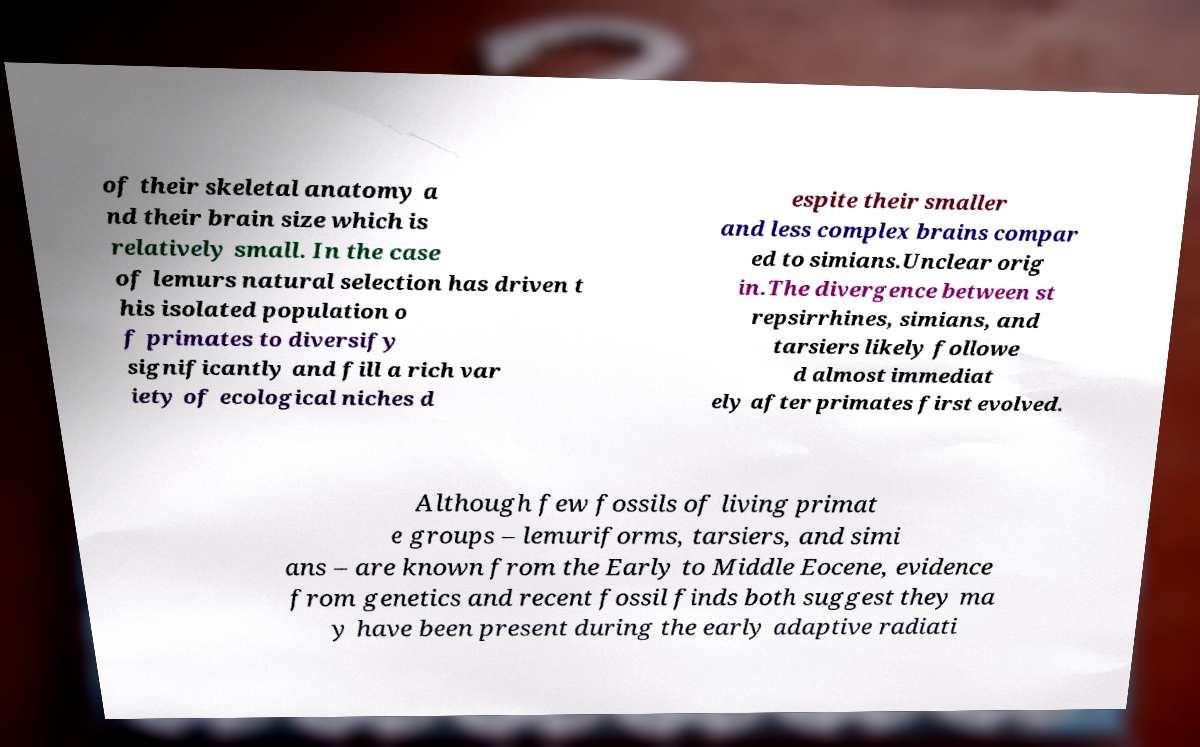There's text embedded in this image that I need extracted. Can you transcribe it verbatim? of their skeletal anatomy a nd their brain size which is relatively small. In the case of lemurs natural selection has driven t his isolated population o f primates to diversify significantly and fill a rich var iety of ecological niches d espite their smaller and less complex brains compar ed to simians.Unclear orig in.The divergence between st repsirrhines, simians, and tarsiers likely followe d almost immediat ely after primates first evolved. Although few fossils of living primat e groups – lemuriforms, tarsiers, and simi ans – are known from the Early to Middle Eocene, evidence from genetics and recent fossil finds both suggest they ma y have been present during the early adaptive radiati 